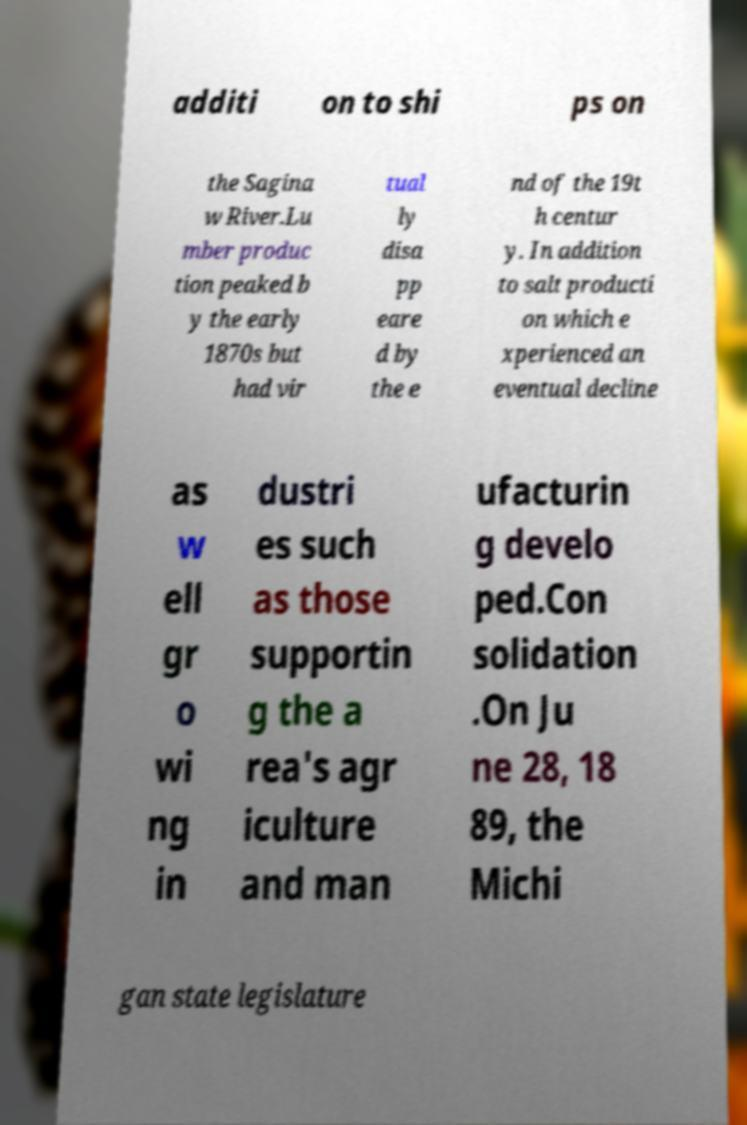What messages or text are displayed in this image? I need them in a readable, typed format. additi on to shi ps on the Sagina w River.Lu mber produc tion peaked b y the early 1870s but had vir tual ly disa pp eare d by the e nd of the 19t h centur y. In addition to salt producti on which e xperienced an eventual decline as w ell gr o wi ng in dustri es such as those supportin g the a rea's agr iculture and man ufacturin g develo ped.Con solidation .On Ju ne 28, 18 89, the Michi gan state legislature 